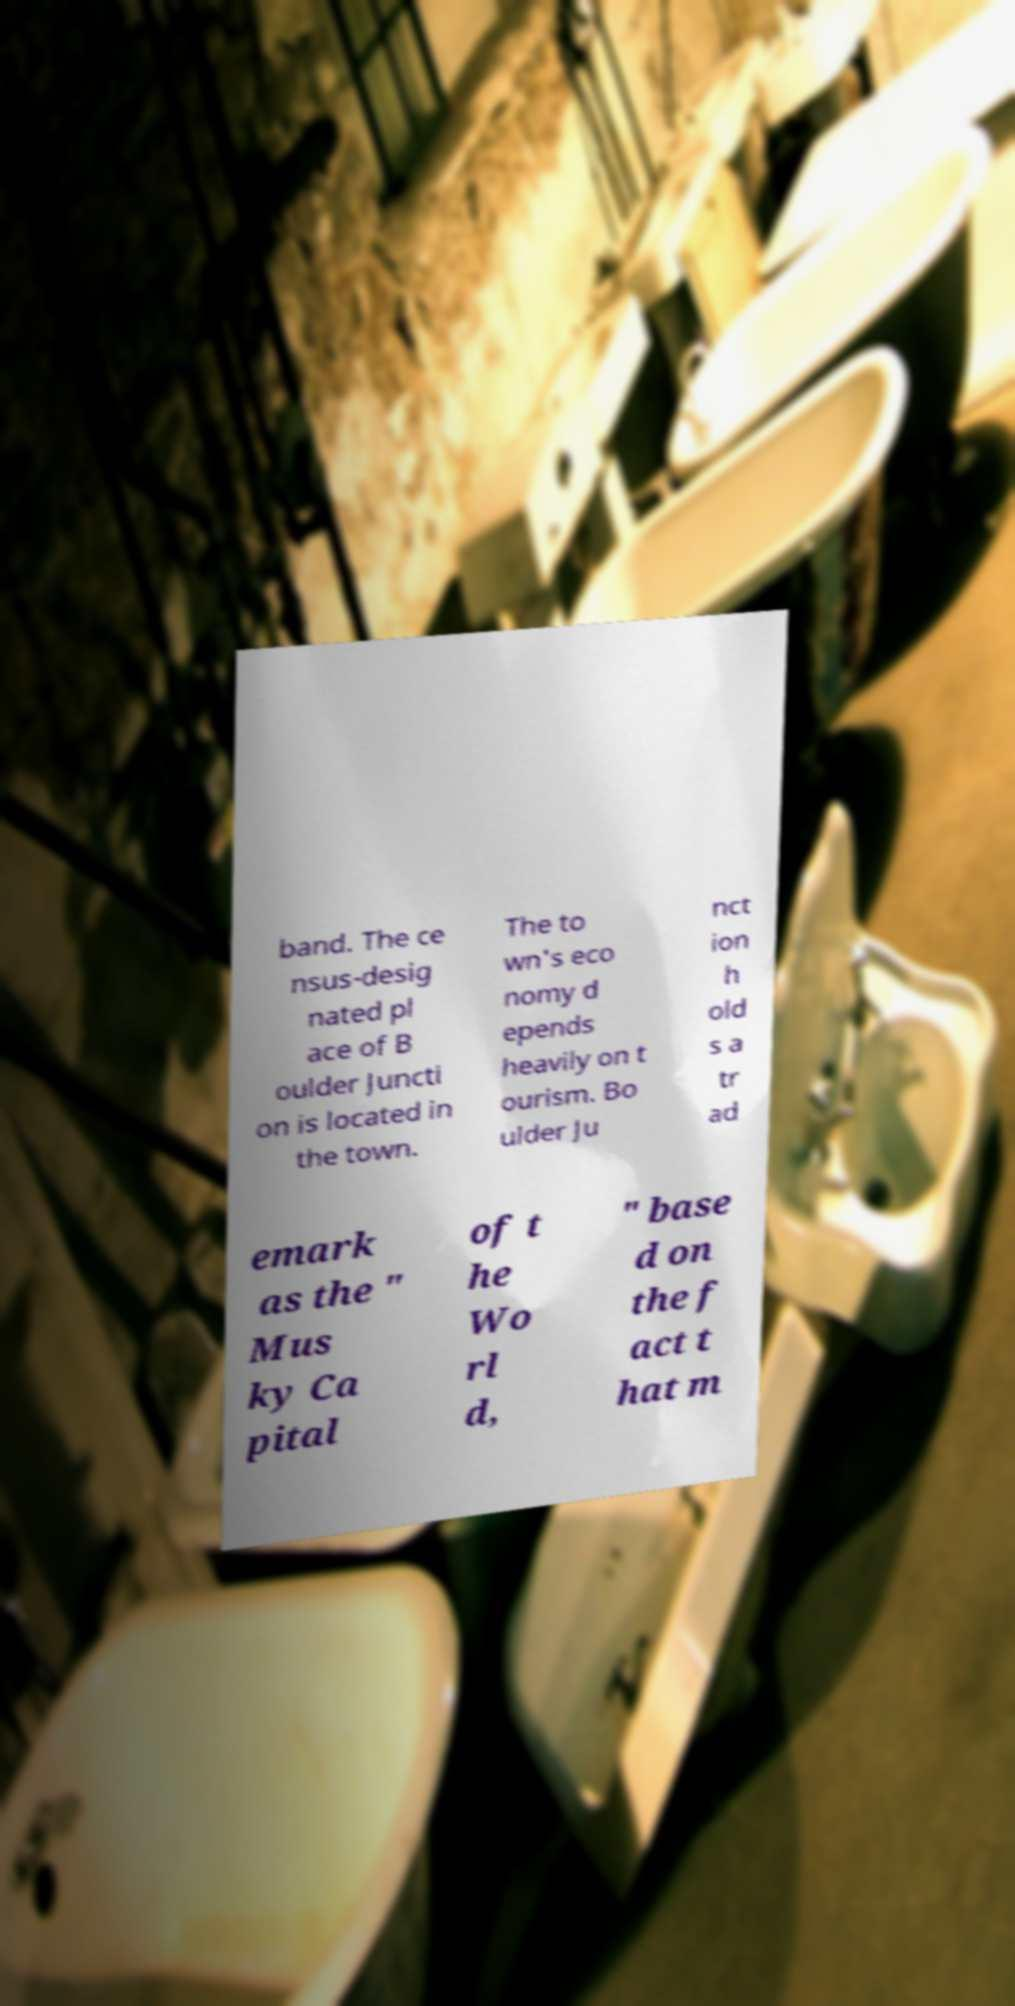I need the written content from this picture converted into text. Can you do that? band. The ce nsus-desig nated pl ace of B oulder Juncti on is located in the town. The to wn's eco nomy d epends heavily on t ourism. Bo ulder Ju nct ion h old s a tr ad emark as the " Mus ky Ca pital of t he Wo rl d, " base d on the f act t hat m 